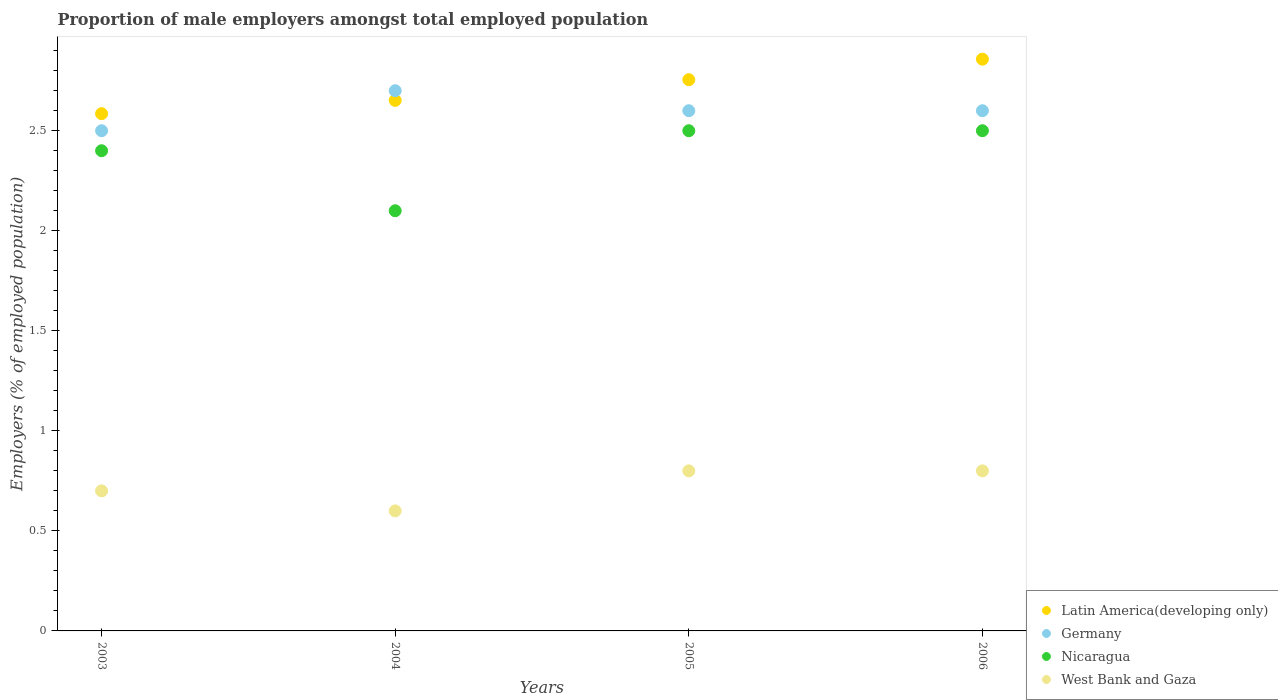What is the proportion of male employers in Latin America(developing only) in 2004?
Make the answer very short. 2.65. Across all years, what is the maximum proportion of male employers in Nicaragua?
Offer a very short reply. 2.5. Across all years, what is the minimum proportion of male employers in Latin America(developing only)?
Ensure brevity in your answer.  2.59. In which year was the proportion of male employers in West Bank and Gaza maximum?
Ensure brevity in your answer.  2005. What is the total proportion of male employers in Nicaragua in the graph?
Your answer should be very brief. 9.5. What is the difference between the proportion of male employers in Germany in 2003 and that in 2005?
Give a very brief answer. -0.1. What is the difference between the proportion of male employers in Nicaragua in 2004 and the proportion of male employers in Latin America(developing only) in 2005?
Offer a terse response. -0.66. What is the average proportion of male employers in Germany per year?
Your answer should be compact. 2.6. In the year 2004, what is the difference between the proportion of male employers in Germany and proportion of male employers in West Bank and Gaza?
Make the answer very short. 2.1. What is the ratio of the proportion of male employers in Germany in 2005 to that in 2006?
Your answer should be compact. 1. What is the difference between the highest and the lowest proportion of male employers in Latin America(developing only)?
Give a very brief answer. 0.27. Is the sum of the proportion of male employers in Latin America(developing only) in 2003 and 2006 greater than the maximum proportion of male employers in Germany across all years?
Your response must be concise. Yes. Is it the case that in every year, the sum of the proportion of male employers in West Bank and Gaza and proportion of male employers in Latin America(developing only)  is greater than the sum of proportion of male employers in Nicaragua and proportion of male employers in Germany?
Provide a short and direct response. Yes. Is it the case that in every year, the sum of the proportion of male employers in West Bank and Gaza and proportion of male employers in Nicaragua  is greater than the proportion of male employers in Germany?
Keep it short and to the point. No. Is the proportion of male employers in Latin America(developing only) strictly greater than the proportion of male employers in West Bank and Gaza over the years?
Keep it short and to the point. Yes. What is the difference between two consecutive major ticks on the Y-axis?
Your response must be concise. 0.5. Does the graph contain any zero values?
Provide a short and direct response. No. Does the graph contain grids?
Your answer should be compact. No. How many legend labels are there?
Your answer should be very brief. 4. How are the legend labels stacked?
Give a very brief answer. Vertical. What is the title of the graph?
Give a very brief answer. Proportion of male employers amongst total employed population. Does "Turkmenistan" appear as one of the legend labels in the graph?
Offer a terse response. No. What is the label or title of the X-axis?
Your response must be concise. Years. What is the label or title of the Y-axis?
Offer a terse response. Employers (% of employed population). What is the Employers (% of employed population) in Latin America(developing only) in 2003?
Ensure brevity in your answer.  2.59. What is the Employers (% of employed population) in Nicaragua in 2003?
Keep it short and to the point. 2.4. What is the Employers (% of employed population) of West Bank and Gaza in 2003?
Your answer should be compact. 0.7. What is the Employers (% of employed population) of Latin America(developing only) in 2004?
Your answer should be compact. 2.65. What is the Employers (% of employed population) of Germany in 2004?
Offer a very short reply. 2.7. What is the Employers (% of employed population) of Nicaragua in 2004?
Ensure brevity in your answer.  2.1. What is the Employers (% of employed population) of West Bank and Gaza in 2004?
Give a very brief answer. 0.6. What is the Employers (% of employed population) of Latin America(developing only) in 2005?
Your response must be concise. 2.76. What is the Employers (% of employed population) in Germany in 2005?
Your answer should be very brief. 2.6. What is the Employers (% of employed population) in Nicaragua in 2005?
Keep it short and to the point. 2.5. What is the Employers (% of employed population) of West Bank and Gaza in 2005?
Keep it short and to the point. 0.8. What is the Employers (% of employed population) in Latin America(developing only) in 2006?
Your response must be concise. 2.86. What is the Employers (% of employed population) in Germany in 2006?
Keep it short and to the point. 2.6. What is the Employers (% of employed population) of West Bank and Gaza in 2006?
Make the answer very short. 0.8. Across all years, what is the maximum Employers (% of employed population) in Latin America(developing only)?
Your answer should be compact. 2.86. Across all years, what is the maximum Employers (% of employed population) of Germany?
Your answer should be very brief. 2.7. Across all years, what is the maximum Employers (% of employed population) of West Bank and Gaza?
Give a very brief answer. 0.8. Across all years, what is the minimum Employers (% of employed population) of Latin America(developing only)?
Your answer should be compact. 2.59. Across all years, what is the minimum Employers (% of employed population) of Nicaragua?
Make the answer very short. 2.1. Across all years, what is the minimum Employers (% of employed population) in West Bank and Gaza?
Offer a terse response. 0.6. What is the total Employers (% of employed population) in Latin America(developing only) in the graph?
Keep it short and to the point. 10.85. What is the total Employers (% of employed population) of Nicaragua in the graph?
Provide a succinct answer. 9.5. What is the difference between the Employers (% of employed population) of Latin America(developing only) in 2003 and that in 2004?
Make the answer very short. -0.07. What is the difference between the Employers (% of employed population) in Latin America(developing only) in 2003 and that in 2005?
Your answer should be compact. -0.17. What is the difference between the Employers (% of employed population) in Nicaragua in 2003 and that in 2005?
Offer a terse response. -0.1. What is the difference between the Employers (% of employed population) in West Bank and Gaza in 2003 and that in 2005?
Make the answer very short. -0.1. What is the difference between the Employers (% of employed population) in Latin America(developing only) in 2003 and that in 2006?
Provide a succinct answer. -0.27. What is the difference between the Employers (% of employed population) in Nicaragua in 2003 and that in 2006?
Your answer should be very brief. -0.1. What is the difference between the Employers (% of employed population) of Latin America(developing only) in 2004 and that in 2005?
Your answer should be compact. -0.1. What is the difference between the Employers (% of employed population) in Germany in 2004 and that in 2005?
Your answer should be compact. 0.1. What is the difference between the Employers (% of employed population) in Latin America(developing only) in 2004 and that in 2006?
Your answer should be compact. -0.21. What is the difference between the Employers (% of employed population) in Germany in 2004 and that in 2006?
Your answer should be very brief. 0.1. What is the difference between the Employers (% of employed population) of West Bank and Gaza in 2004 and that in 2006?
Provide a short and direct response. -0.2. What is the difference between the Employers (% of employed population) of Latin America(developing only) in 2005 and that in 2006?
Offer a terse response. -0.1. What is the difference between the Employers (% of employed population) of Germany in 2005 and that in 2006?
Provide a succinct answer. 0. What is the difference between the Employers (% of employed population) in Latin America(developing only) in 2003 and the Employers (% of employed population) in Germany in 2004?
Give a very brief answer. -0.11. What is the difference between the Employers (% of employed population) of Latin America(developing only) in 2003 and the Employers (% of employed population) of Nicaragua in 2004?
Keep it short and to the point. 0.49. What is the difference between the Employers (% of employed population) in Latin America(developing only) in 2003 and the Employers (% of employed population) in West Bank and Gaza in 2004?
Offer a very short reply. 1.99. What is the difference between the Employers (% of employed population) of Germany in 2003 and the Employers (% of employed population) of West Bank and Gaza in 2004?
Make the answer very short. 1.9. What is the difference between the Employers (% of employed population) of Nicaragua in 2003 and the Employers (% of employed population) of West Bank and Gaza in 2004?
Offer a very short reply. 1.8. What is the difference between the Employers (% of employed population) in Latin America(developing only) in 2003 and the Employers (% of employed population) in Germany in 2005?
Offer a very short reply. -0.01. What is the difference between the Employers (% of employed population) of Latin America(developing only) in 2003 and the Employers (% of employed population) of Nicaragua in 2005?
Your answer should be very brief. 0.09. What is the difference between the Employers (% of employed population) of Latin America(developing only) in 2003 and the Employers (% of employed population) of West Bank and Gaza in 2005?
Give a very brief answer. 1.79. What is the difference between the Employers (% of employed population) of Germany in 2003 and the Employers (% of employed population) of West Bank and Gaza in 2005?
Provide a succinct answer. 1.7. What is the difference between the Employers (% of employed population) of Nicaragua in 2003 and the Employers (% of employed population) of West Bank and Gaza in 2005?
Make the answer very short. 1.6. What is the difference between the Employers (% of employed population) in Latin America(developing only) in 2003 and the Employers (% of employed population) in Germany in 2006?
Keep it short and to the point. -0.01. What is the difference between the Employers (% of employed population) in Latin America(developing only) in 2003 and the Employers (% of employed population) in Nicaragua in 2006?
Make the answer very short. 0.09. What is the difference between the Employers (% of employed population) in Latin America(developing only) in 2003 and the Employers (% of employed population) in West Bank and Gaza in 2006?
Your answer should be very brief. 1.79. What is the difference between the Employers (% of employed population) of Germany in 2003 and the Employers (% of employed population) of Nicaragua in 2006?
Keep it short and to the point. 0. What is the difference between the Employers (% of employed population) in Germany in 2003 and the Employers (% of employed population) in West Bank and Gaza in 2006?
Offer a very short reply. 1.7. What is the difference between the Employers (% of employed population) in Nicaragua in 2003 and the Employers (% of employed population) in West Bank and Gaza in 2006?
Provide a succinct answer. 1.6. What is the difference between the Employers (% of employed population) of Latin America(developing only) in 2004 and the Employers (% of employed population) of Germany in 2005?
Offer a very short reply. 0.05. What is the difference between the Employers (% of employed population) of Latin America(developing only) in 2004 and the Employers (% of employed population) of Nicaragua in 2005?
Give a very brief answer. 0.15. What is the difference between the Employers (% of employed population) of Latin America(developing only) in 2004 and the Employers (% of employed population) of West Bank and Gaza in 2005?
Make the answer very short. 1.85. What is the difference between the Employers (% of employed population) in Germany in 2004 and the Employers (% of employed population) in Nicaragua in 2005?
Provide a succinct answer. 0.2. What is the difference between the Employers (% of employed population) of Latin America(developing only) in 2004 and the Employers (% of employed population) of Germany in 2006?
Your response must be concise. 0.05. What is the difference between the Employers (% of employed population) of Latin America(developing only) in 2004 and the Employers (% of employed population) of Nicaragua in 2006?
Your answer should be very brief. 0.15. What is the difference between the Employers (% of employed population) of Latin America(developing only) in 2004 and the Employers (% of employed population) of West Bank and Gaza in 2006?
Make the answer very short. 1.85. What is the difference between the Employers (% of employed population) in Germany in 2004 and the Employers (% of employed population) in Nicaragua in 2006?
Make the answer very short. 0.2. What is the difference between the Employers (% of employed population) in Nicaragua in 2004 and the Employers (% of employed population) in West Bank and Gaza in 2006?
Provide a short and direct response. 1.3. What is the difference between the Employers (% of employed population) of Latin America(developing only) in 2005 and the Employers (% of employed population) of Germany in 2006?
Your answer should be very brief. 0.16. What is the difference between the Employers (% of employed population) in Latin America(developing only) in 2005 and the Employers (% of employed population) in Nicaragua in 2006?
Make the answer very short. 0.26. What is the difference between the Employers (% of employed population) in Latin America(developing only) in 2005 and the Employers (% of employed population) in West Bank and Gaza in 2006?
Ensure brevity in your answer.  1.96. What is the difference between the Employers (% of employed population) in Germany in 2005 and the Employers (% of employed population) in Nicaragua in 2006?
Offer a terse response. 0.1. What is the difference between the Employers (% of employed population) of Nicaragua in 2005 and the Employers (% of employed population) of West Bank and Gaza in 2006?
Ensure brevity in your answer.  1.7. What is the average Employers (% of employed population) in Latin America(developing only) per year?
Your answer should be compact. 2.71. What is the average Employers (% of employed population) of Nicaragua per year?
Give a very brief answer. 2.38. What is the average Employers (% of employed population) in West Bank and Gaza per year?
Ensure brevity in your answer.  0.72. In the year 2003, what is the difference between the Employers (% of employed population) in Latin America(developing only) and Employers (% of employed population) in Germany?
Your response must be concise. 0.09. In the year 2003, what is the difference between the Employers (% of employed population) of Latin America(developing only) and Employers (% of employed population) of Nicaragua?
Provide a short and direct response. 0.19. In the year 2003, what is the difference between the Employers (% of employed population) of Latin America(developing only) and Employers (% of employed population) of West Bank and Gaza?
Ensure brevity in your answer.  1.89. In the year 2003, what is the difference between the Employers (% of employed population) in Nicaragua and Employers (% of employed population) in West Bank and Gaza?
Your response must be concise. 1.7. In the year 2004, what is the difference between the Employers (% of employed population) in Latin America(developing only) and Employers (% of employed population) in Germany?
Keep it short and to the point. -0.05. In the year 2004, what is the difference between the Employers (% of employed population) of Latin America(developing only) and Employers (% of employed population) of Nicaragua?
Offer a terse response. 0.55. In the year 2004, what is the difference between the Employers (% of employed population) of Latin America(developing only) and Employers (% of employed population) of West Bank and Gaza?
Provide a short and direct response. 2.05. In the year 2004, what is the difference between the Employers (% of employed population) of Germany and Employers (% of employed population) of West Bank and Gaza?
Make the answer very short. 2.1. In the year 2005, what is the difference between the Employers (% of employed population) in Latin America(developing only) and Employers (% of employed population) in Germany?
Ensure brevity in your answer.  0.16. In the year 2005, what is the difference between the Employers (% of employed population) in Latin America(developing only) and Employers (% of employed population) in Nicaragua?
Your response must be concise. 0.26. In the year 2005, what is the difference between the Employers (% of employed population) in Latin America(developing only) and Employers (% of employed population) in West Bank and Gaza?
Give a very brief answer. 1.96. In the year 2005, what is the difference between the Employers (% of employed population) in Germany and Employers (% of employed population) in Nicaragua?
Keep it short and to the point. 0.1. In the year 2005, what is the difference between the Employers (% of employed population) in Germany and Employers (% of employed population) in West Bank and Gaza?
Make the answer very short. 1.8. In the year 2006, what is the difference between the Employers (% of employed population) in Latin America(developing only) and Employers (% of employed population) in Germany?
Give a very brief answer. 0.26. In the year 2006, what is the difference between the Employers (% of employed population) of Latin America(developing only) and Employers (% of employed population) of Nicaragua?
Make the answer very short. 0.36. In the year 2006, what is the difference between the Employers (% of employed population) in Latin America(developing only) and Employers (% of employed population) in West Bank and Gaza?
Provide a short and direct response. 2.06. In the year 2006, what is the difference between the Employers (% of employed population) of Nicaragua and Employers (% of employed population) of West Bank and Gaza?
Keep it short and to the point. 1.7. What is the ratio of the Employers (% of employed population) in Latin America(developing only) in 2003 to that in 2004?
Provide a succinct answer. 0.97. What is the ratio of the Employers (% of employed population) of Germany in 2003 to that in 2004?
Give a very brief answer. 0.93. What is the ratio of the Employers (% of employed population) in West Bank and Gaza in 2003 to that in 2004?
Ensure brevity in your answer.  1.17. What is the ratio of the Employers (% of employed population) in Latin America(developing only) in 2003 to that in 2005?
Give a very brief answer. 0.94. What is the ratio of the Employers (% of employed population) of Germany in 2003 to that in 2005?
Offer a terse response. 0.96. What is the ratio of the Employers (% of employed population) of Nicaragua in 2003 to that in 2005?
Offer a terse response. 0.96. What is the ratio of the Employers (% of employed population) of West Bank and Gaza in 2003 to that in 2005?
Offer a terse response. 0.88. What is the ratio of the Employers (% of employed population) of Latin America(developing only) in 2003 to that in 2006?
Make the answer very short. 0.9. What is the ratio of the Employers (% of employed population) of Germany in 2003 to that in 2006?
Provide a succinct answer. 0.96. What is the ratio of the Employers (% of employed population) of Nicaragua in 2003 to that in 2006?
Your answer should be very brief. 0.96. What is the ratio of the Employers (% of employed population) in Latin America(developing only) in 2004 to that in 2005?
Give a very brief answer. 0.96. What is the ratio of the Employers (% of employed population) in Nicaragua in 2004 to that in 2005?
Provide a short and direct response. 0.84. What is the ratio of the Employers (% of employed population) in Latin America(developing only) in 2004 to that in 2006?
Keep it short and to the point. 0.93. What is the ratio of the Employers (% of employed population) of Germany in 2004 to that in 2006?
Provide a succinct answer. 1.04. What is the ratio of the Employers (% of employed population) of Nicaragua in 2004 to that in 2006?
Keep it short and to the point. 0.84. What is the ratio of the Employers (% of employed population) of West Bank and Gaza in 2004 to that in 2006?
Make the answer very short. 0.75. What is the ratio of the Employers (% of employed population) in Latin America(developing only) in 2005 to that in 2006?
Provide a short and direct response. 0.96. What is the ratio of the Employers (% of employed population) of West Bank and Gaza in 2005 to that in 2006?
Your answer should be very brief. 1. What is the difference between the highest and the second highest Employers (% of employed population) of Latin America(developing only)?
Your answer should be compact. 0.1. What is the difference between the highest and the second highest Employers (% of employed population) of Nicaragua?
Ensure brevity in your answer.  0. What is the difference between the highest and the second highest Employers (% of employed population) in West Bank and Gaza?
Provide a succinct answer. 0. What is the difference between the highest and the lowest Employers (% of employed population) of Latin America(developing only)?
Provide a succinct answer. 0.27. What is the difference between the highest and the lowest Employers (% of employed population) in Germany?
Your answer should be very brief. 0.2. What is the difference between the highest and the lowest Employers (% of employed population) of Nicaragua?
Keep it short and to the point. 0.4. 